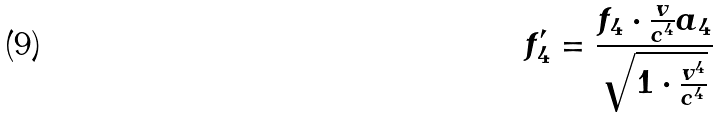Convert formula to latex. <formula><loc_0><loc_0><loc_500><loc_500>f _ { 4 } ^ { \prime } = \frac { f _ { 4 } \cdot \frac { v } { c ^ { 4 } } a _ { 4 } } { \sqrt { 1 \cdot \frac { v ^ { 4 } } { c ^ { 4 } } } }</formula> 